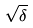<formula> <loc_0><loc_0><loc_500><loc_500>\sqrt { \delta }</formula> 